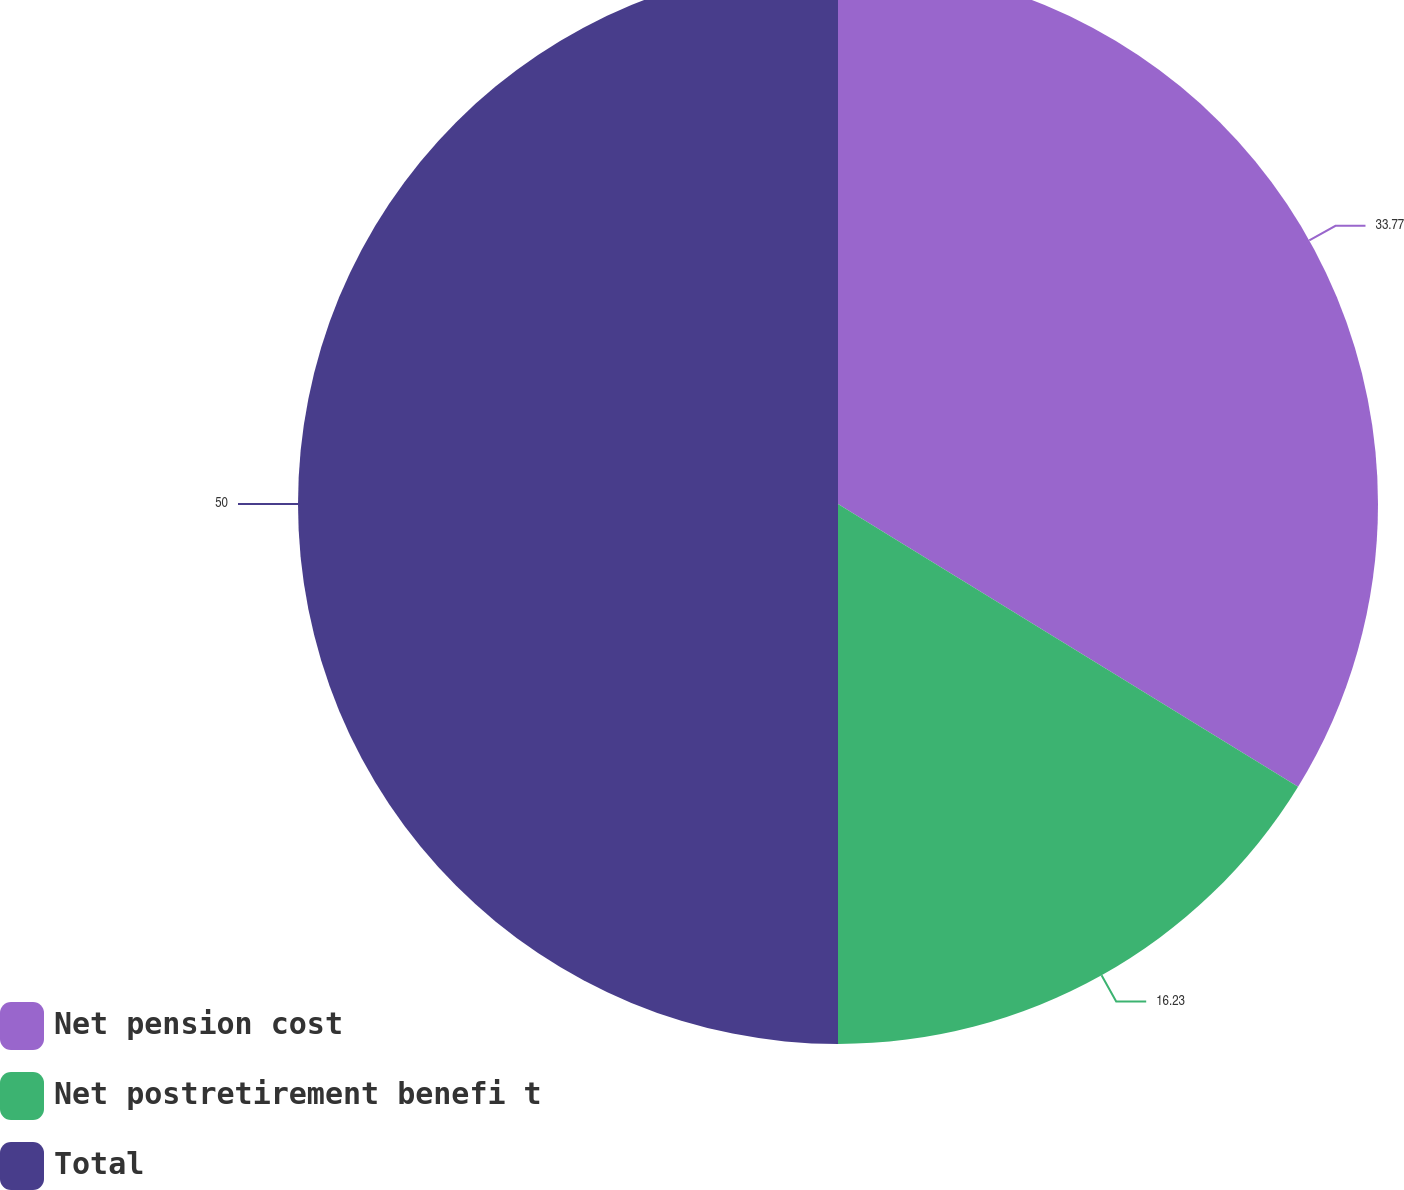Convert chart to OTSL. <chart><loc_0><loc_0><loc_500><loc_500><pie_chart><fcel>Net pension cost<fcel>Net postretirement benefi t<fcel>Total<nl><fcel>33.77%<fcel>16.23%<fcel>50.0%<nl></chart> 